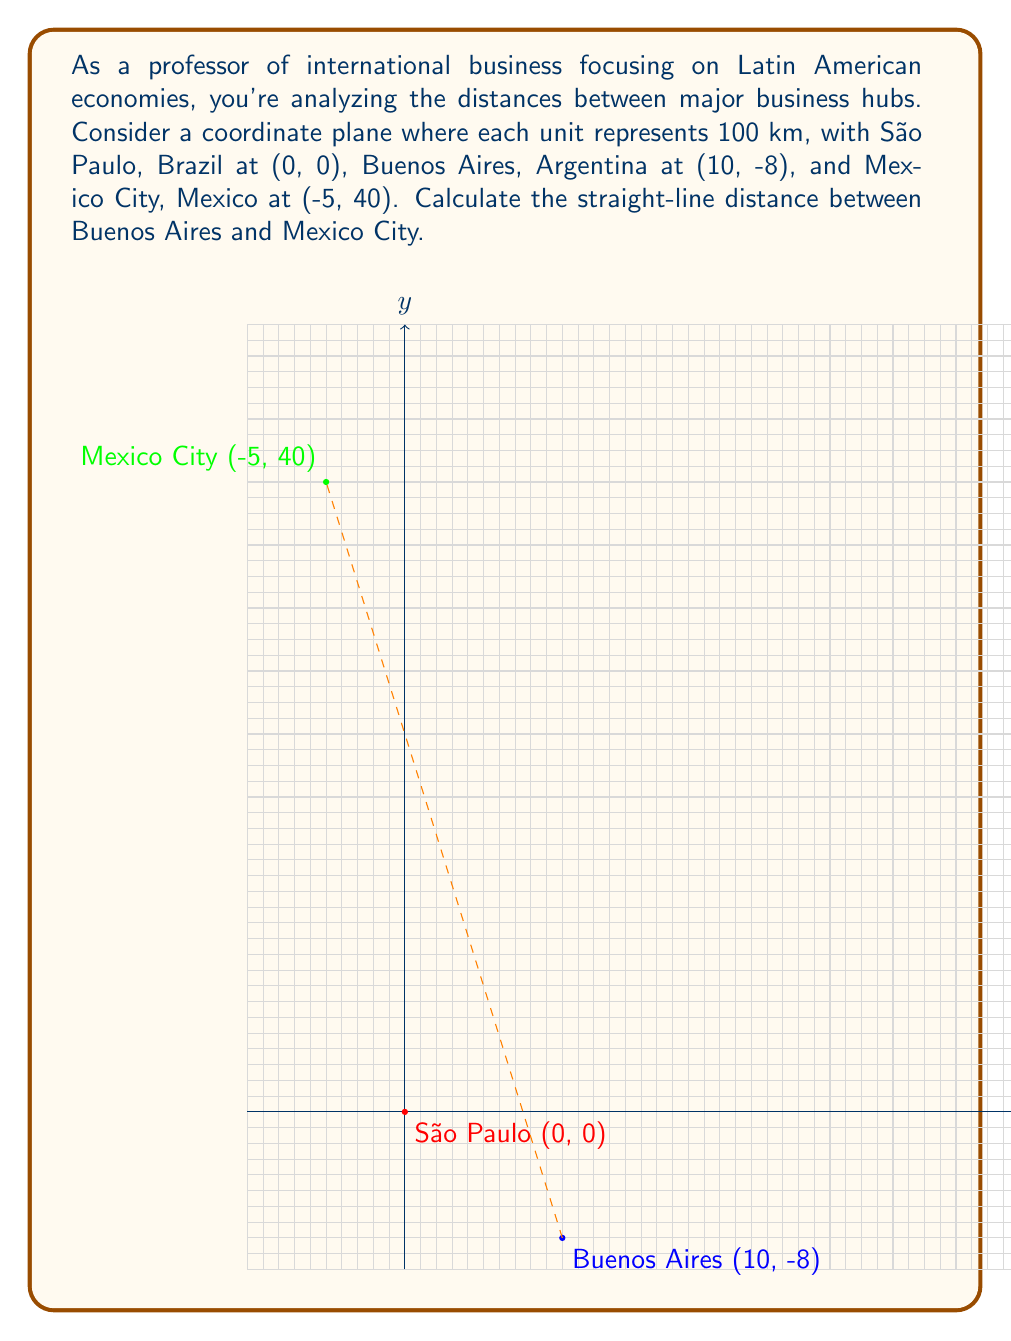Teach me how to tackle this problem. To calculate the straight-line distance between Buenos Aires and Mexico City, we can use the distance formula derived from the Pythagorean theorem:

$$d = \sqrt{(x_2 - x_1)^2 + (y_2 - y_1)^2}$$

Where $(x_1, y_1)$ are the coordinates of Buenos Aires (10, -8) and $(x_2, y_2)$ are the coordinates of Mexico City (-5, 40).

Step 1: Identify the coordinates
Buenos Aires: $(x_1, y_1) = (10, -8)$
Mexico City: $(x_2, y_2) = (-5, 40)$

Step 2: Apply the distance formula
$$d = \sqrt{(-5 - 10)^2 + (40 - (-8))^2}$$

Step 3: Simplify the expressions inside the parentheses
$$d = \sqrt{(-15)^2 + (48)^2}$$

Step 4: Calculate the squares
$$d = \sqrt{225 + 2304}$$

Step 5: Add the terms under the square root
$$d = \sqrt{2529}$$

Step 6: Calculate the square root
$$d = 50.29$$

Step 7: Interpret the result
Since each unit represents 100 km, we multiply the result by 100:

$$50.29 \times 100 = 5029 \text{ km}$$

Therefore, the straight-line distance between Buenos Aires and Mexico City is approximately 5029 km.
Answer: 5029 km 